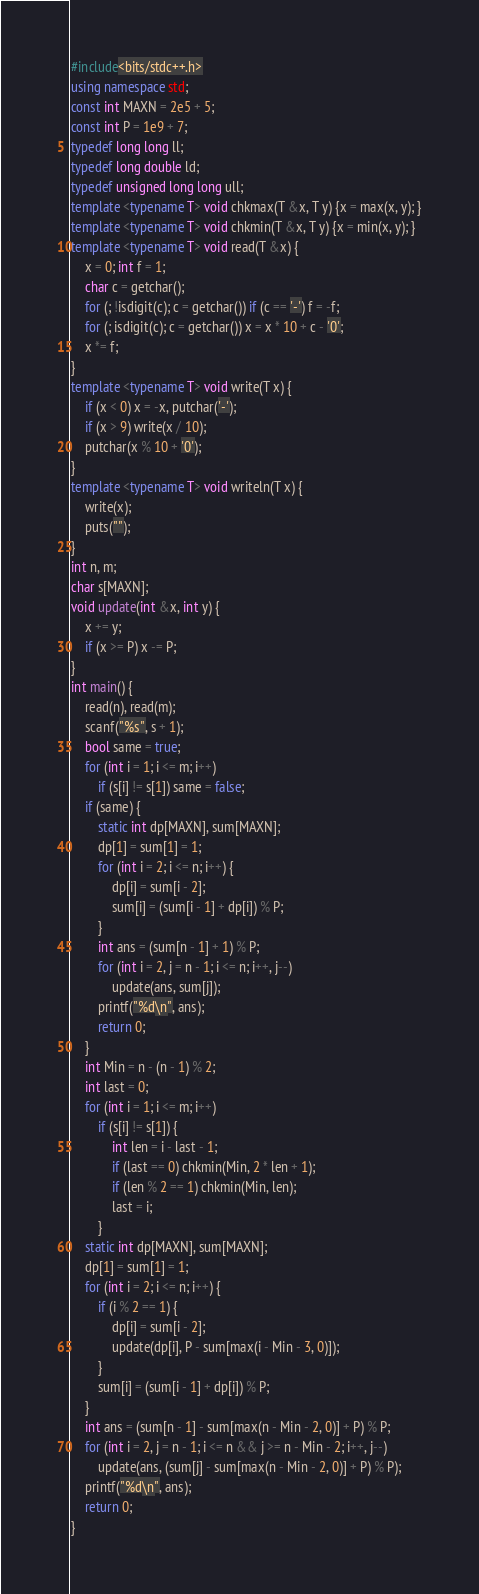Convert code to text. <code><loc_0><loc_0><loc_500><loc_500><_C++_>#include<bits/stdc++.h>
using namespace std;
const int MAXN = 2e5 + 5;
const int P = 1e9 + 7;
typedef long long ll;
typedef long double ld;
typedef unsigned long long ull;
template <typename T> void chkmax(T &x, T y) {x = max(x, y); }
template <typename T> void chkmin(T &x, T y) {x = min(x, y); } 
template <typename T> void read(T &x) {
	x = 0; int f = 1;
	char c = getchar();
	for (; !isdigit(c); c = getchar()) if (c == '-') f = -f;
	for (; isdigit(c); c = getchar()) x = x * 10 + c - '0';
	x *= f;
}
template <typename T> void write(T x) {
	if (x < 0) x = -x, putchar('-');
	if (x > 9) write(x / 10);
	putchar(x % 10 + '0');
}
template <typename T> void writeln(T x) {
	write(x);
	puts("");
}
int n, m;
char s[MAXN];
void update(int &x, int y) {
	x += y;
	if (x >= P) x -= P;
}
int main() {
	read(n), read(m);
	scanf("%s", s + 1);
	bool same = true;
	for (int i = 1; i <= m; i++)
		if (s[i] != s[1]) same = false;
	if (same) {
		static int dp[MAXN], sum[MAXN];
		dp[1] = sum[1] = 1;
		for (int i = 2; i <= n; i++) {
			dp[i] = sum[i - 2];
			sum[i] = (sum[i - 1] + dp[i]) % P;
		}
		int ans = (sum[n - 1] + 1) % P;
		for (int i = 2, j = n - 1; i <= n; i++, j--)
			update(ans, sum[j]);
		printf("%d\n", ans);
		return 0;
	}
	int Min = n - (n - 1) % 2;
	int last = 0;
	for (int i = 1; i <= m; i++)
		if (s[i] != s[1]) {
			int len = i - last - 1;
			if (last == 0) chkmin(Min, 2 * len + 1);
			if (len % 2 == 1) chkmin(Min, len);
			last = i;
		}
	static int dp[MAXN], sum[MAXN];
	dp[1] = sum[1] = 1;
	for (int i = 2; i <= n; i++) {
		if (i % 2 == 1) {
			dp[i] = sum[i - 2];
			update(dp[i], P - sum[max(i - Min - 3, 0)]);
		}
		sum[i] = (sum[i - 1] + dp[i]) % P;
	}
	int ans = (sum[n - 1] - sum[max(n - Min - 2, 0)] + P) % P;
	for (int i = 2, j = n - 1; i <= n && j >= n - Min - 2; i++, j--)
		update(ans, (sum[j] - sum[max(n - Min - 2, 0)] + P) % P);
	printf("%d\n", ans);
	return 0;
}</code> 